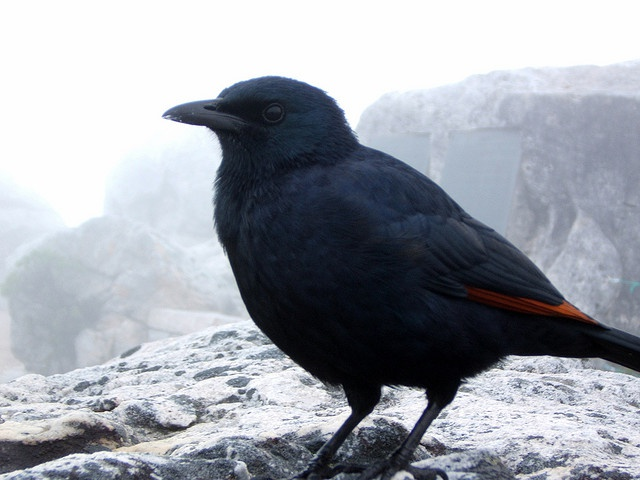Describe the objects in this image and their specific colors. I can see a bird in white, black, gray, and darkblue tones in this image. 